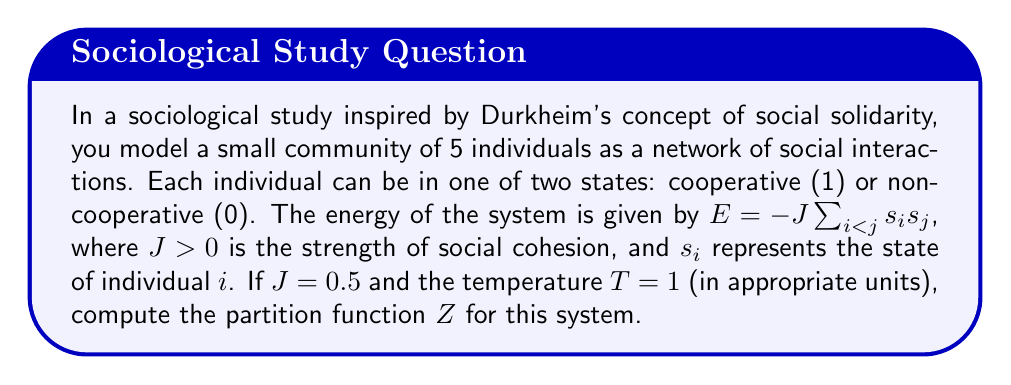Provide a solution to this math problem. To solve this problem, we'll follow these steps:

1) The partition function is given by:
   $$Z = \sum_{\text{all states}} e^{-\beta E}$$
   where $\beta = \frac{1}{k_BT}$, and $k_B$ is Boltzmann's constant.

2) In this case, $\beta = 1$ since $T = 1$ in the given units.

3) There are $2^5 = 32$ possible states in total, as each of the 5 individuals can be in one of two states.

4) We need to calculate the energy for each state and sum $e^{-E}$ over all states.

5) The energy depends on the number of cooperative pairs. Let's count:
   - 0 cooperative: 1 state, 0 pairs, $E = 0$
   - 1 cooperative: 5 states, 0 pairs, $E = 0$
   - 2 cooperative: 10 states, 1 pair, $E = -0.5J = -0.25$
   - 3 cooperative: 10 states, 3 pairs, $E = -1.5J = -0.75$
   - 4 cooperative: 5 states, 6 pairs, $E = -3J = -1.5$
   - 5 cooperative: 1 state, 10 pairs, $E = -5J = -2.5$

6) Now we can calculate Z:
   $$Z = (1+5)e^0 + 10e^{0.25} + 10e^{0.75} + 5e^{1.5} + 1e^{2.5}$$

7) Evaluating:
   $$Z = 6 + 10(1.2840) + 10(2.1170) + 5(4.4817) + 12.1825$$
   $$Z = 6 + 12.8400 + 21.1700 + 22.4085 + 12.1825$$
   $$Z = 74.6010$$
Answer: $Z \approx 74.6010$ 